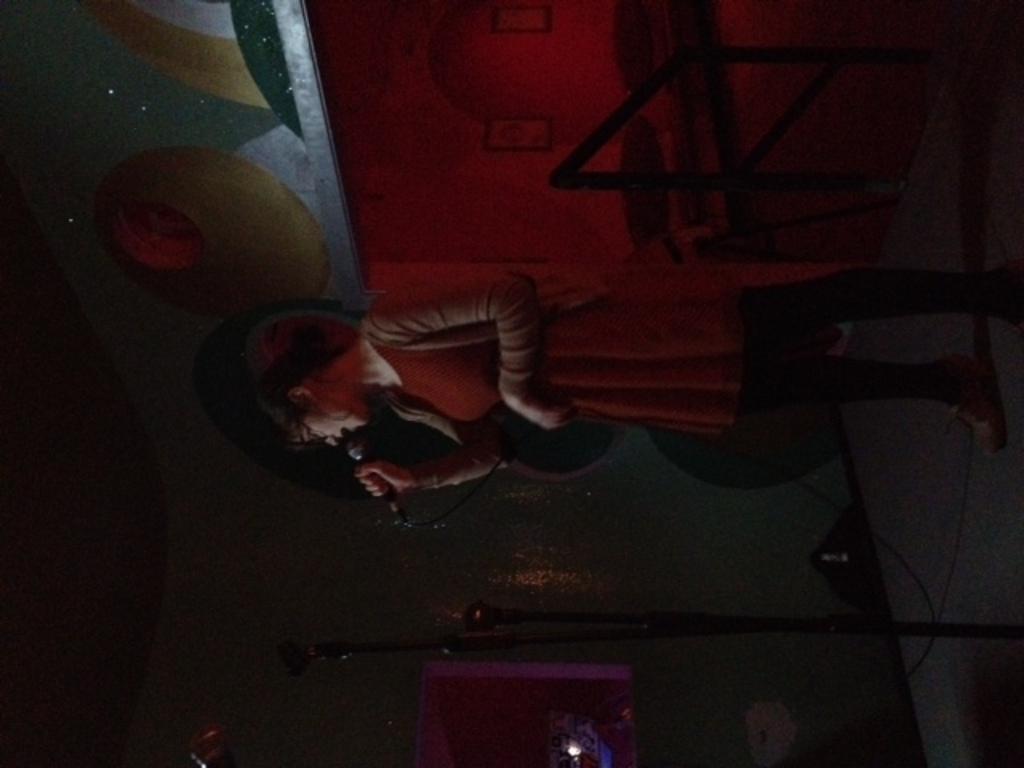Please provide a concise description of this image. In the center of the image we can see a lady is standing and holding a mic and singing. At the bottom of the image we can see the mics with stands and wires, lights. On the right side of the image we can see the floor. In the background of the image we can see the wall. 